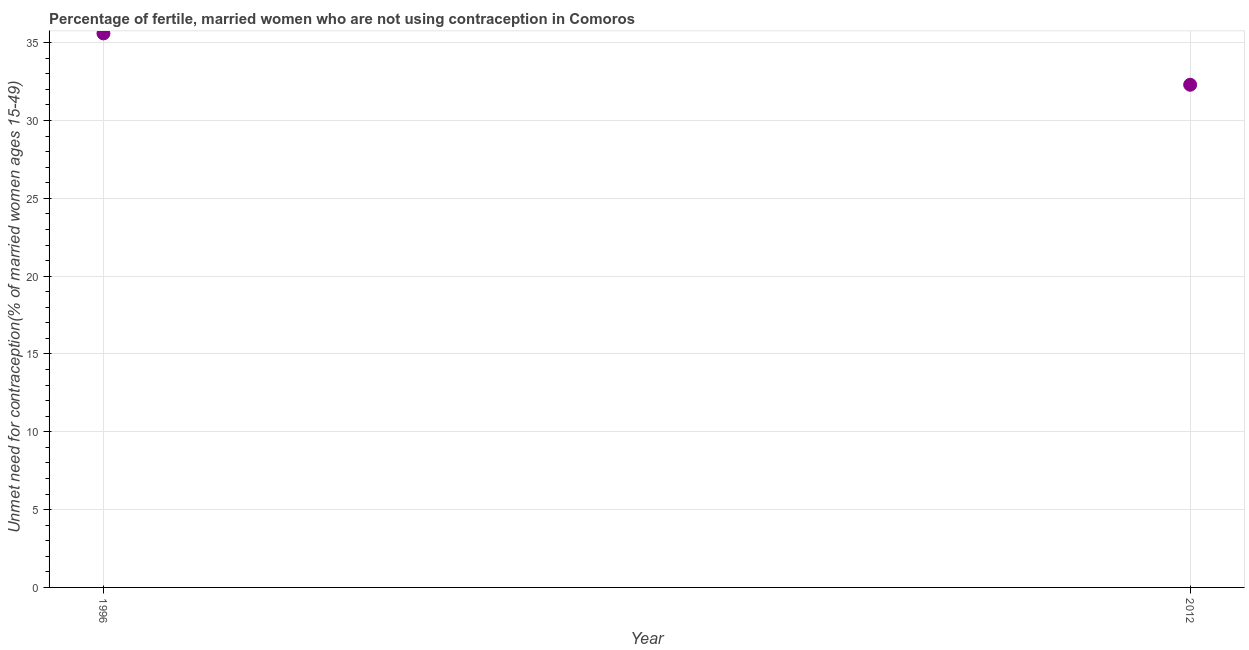What is the number of married women who are not using contraception in 2012?
Keep it short and to the point. 32.3. Across all years, what is the maximum number of married women who are not using contraception?
Your answer should be compact. 35.6. Across all years, what is the minimum number of married women who are not using contraception?
Ensure brevity in your answer.  32.3. In which year was the number of married women who are not using contraception maximum?
Your response must be concise. 1996. What is the sum of the number of married women who are not using contraception?
Keep it short and to the point. 67.9. What is the difference between the number of married women who are not using contraception in 1996 and 2012?
Offer a terse response. 3.3. What is the average number of married women who are not using contraception per year?
Ensure brevity in your answer.  33.95. What is the median number of married women who are not using contraception?
Provide a short and direct response. 33.95. What is the ratio of the number of married women who are not using contraception in 1996 to that in 2012?
Keep it short and to the point. 1.1. Is the number of married women who are not using contraception in 1996 less than that in 2012?
Provide a succinct answer. No. In how many years, is the number of married women who are not using contraception greater than the average number of married women who are not using contraception taken over all years?
Provide a succinct answer. 1. Does the number of married women who are not using contraception monotonically increase over the years?
Your response must be concise. No. Are the values on the major ticks of Y-axis written in scientific E-notation?
Offer a terse response. No. Does the graph contain grids?
Offer a terse response. Yes. What is the title of the graph?
Ensure brevity in your answer.  Percentage of fertile, married women who are not using contraception in Comoros. What is the label or title of the X-axis?
Your response must be concise. Year. What is the label or title of the Y-axis?
Offer a very short reply.  Unmet need for contraception(% of married women ages 15-49). What is the  Unmet need for contraception(% of married women ages 15-49) in 1996?
Ensure brevity in your answer.  35.6. What is the  Unmet need for contraception(% of married women ages 15-49) in 2012?
Give a very brief answer. 32.3. What is the ratio of the  Unmet need for contraception(% of married women ages 15-49) in 1996 to that in 2012?
Give a very brief answer. 1.1. 